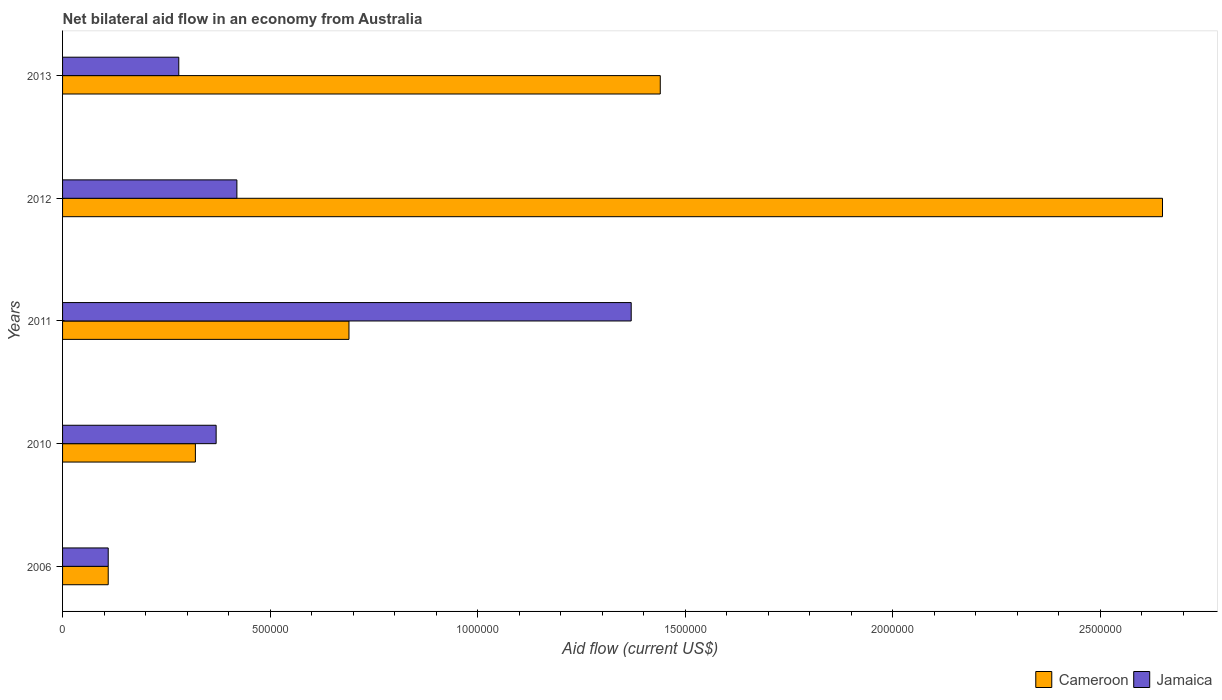How many different coloured bars are there?
Ensure brevity in your answer.  2. How many groups of bars are there?
Give a very brief answer. 5. Are the number of bars per tick equal to the number of legend labels?
Provide a succinct answer. Yes. Are the number of bars on each tick of the Y-axis equal?
Provide a short and direct response. Yes. How many bars are there on the 3rd tick from the top?
Provide a short and direct response. 2. How many bars are there on the 4th tick from the bottom?
Your answer should be compact. 2. Across all years, what is the maximum net bilateral aid flow in Jamaica?
Make the answer very short. 1.37e+06. What is the total net bilateral aid flow in Jamaica in the graph?
Provide a succinct answer. 2.55e+06. What is the difference between the net bilateral aid flow in Cameroon in 2006 and that in 2012?
Offer a terse response. -2.54e+06. What is the difference between the net bilateral aid flow in Jamaica in 2006 and the net bilateral aid flow in Cameroon in 2013?
Give a very brief answer. -1.33e+06. What is the average net bilateral aid flow in Jamaica per year?
Give a very brief answer. 5.10e+05. In how many years, is the net bilateral aid flow in Cameroon greater than 100000 US$?
Provide a succinct answer. 5. What is the ratio of the net bilateral aid flow in Jamaica in 2010 to that in 2011?
Your answer should be compact. 0.27. Is the difference between the net bilateral aid flow in Cameroon in 2010 and 2011 greater than the difference between the net bilateral aid flow in Jamaica in 2010 and 2011?
Give a very brief answer. Yes. What is the difference between the highest and the second highest net bilateral aid flow in Jamaica?
Offer a very short reply. 9.50e+05. What is the difference between the highest and the lowest net bilateral aid flow in Jamaica?
Give a very brief answer. 1.26e+06. Is the sum of the net bilateral aid flow in Jamaica in 2006 and 2013 greater than the maximum net bilateral aid flow in Cameroon across all years?
Offer a very short reply. No. What does the 1st bar from the top in 2006 represents?
Your response must be concise. Jamaica. What does the 2nd bar from the bottom in 2012 represents?
Offer a terse response. Jamaica. How many bars are there?
Keep it short and to the point. 10. What is the difference between two consecutive major ticks on the X-axis?
Provide a short and direct response. 5.00e+05. Are the values on the major ticks of X-axis written in scientific E-notation?
Provide a short and direct response. No. Does the graph contain any zero values?
Your response must be concise. No. How are the legend labels stacked?
Your response must be concise. Horizontal. What is the title of the graph?
Give a very brief answer. Net bilateral aid flow in an economy from Australia. Does "Albania" appear as one of the legend labels in the graph?
Offer a terse response. No. What is the label or title of the X-axis?
Make the answer very short. Aid flow (current US$). What is the Aid flow (current US$) of Cameroon in 2006?
Offer a terse response. 1.10e+05. What is the Aid flow (current US$) in Jamaica in 2006?
Your answer should be very brief. 1.10e+05. What is the Aid flow (current US$) of Cameroon in 2010?
Your answer should be very brief. 3.20e+05. What is the Aid flow (current US$) in Jamaica in 2010?
Provide a succinct answer. 3.70e+05. What is the Aid flow (current US$) of Cameroon in 2011?
Your answer should be compact. 6.90e+05. What is the Aid flow (current US$) of Jamaica in 2011?
Your answer should be compact. 1.37e+06. What is the Aid flow (current US$) of Cameroon in 2012?
Your response must be concise. 2.65e+06. What is the Aid flow (current US$) in Jamaica in 2012?
Provide a succinct answer. 4.20e+05. What is the Aid flow (current US$) of Cameroon in 2013?
Keep it short and to the point. 1.44e+06. What is the Aid flow (current US$) of Jamaica in 2013?
Offer a very short reply. 2.80e+05. Across all years, what is the maximum Aid flow (current US$) of Cameroon?
Make the answer very short. 2.65e+06. Across all years, what is the maximum Aid flow (current US$) of Jamaica?
Give a very brief answer. 1.37e+06. Across all years, what is the minimum Aid flow (current US$) in Cameroon?
Offer a very short reply. 1.10e+05. Across all years, what is the minimum Aid flow (current US$) in Jamaica?
Your answer should be very brief. 1.10e+05. What is the total Aid flow (current US$) of Cameroon in the graph?
Your response must be concise. 5.21e+06. What is the total Aid flow (current US$) in Jamaica in the graph?
Ensure brevity in your answer.  2.55e+06. What is the difference between the Aid flow (current US$) in Cameroon in 2006 and that in 2011?
Your answer should be compact. -5.80e+05. What is the difference between the Aid flow (current US$) of Jamaica in 2006 and that in 2011?
Your response must be concise. -1.26e+06. What is the difference between the Aid flow (current US$) in Cameroon in 2006 and that in 2012?
Ensure brevity in your answer.  -2.54e+06. What is the difference between the Aid flow (current US$) of Jamaica in 2006 and that in 2012?
Make the answer very short. -3.10e+05. What is the difference between the Aid flow (current US$) of Cameroon in 2006 and that in 2013?
Your answer should be very brief. -1.33e+06. What is the difference between the Aid flow (current US$) of Jamaica in 2006 and that in 2013?
Your response must be concise. -1.70e+05. What is the difference between the Aid flow (current US$) in Cameroon in 2010 and that in 2011?
Keep it short and to the point. -3.70e+05. What is the difference between the Aid flow (current US$) in Jamaica in 2010 and that in 2011?
Your answer should be very brief. -1.00e+06. What is the difference between the Aid flow (current US$) in Cameroon in 2010 and that in 2012?
Your response must be concise. -2.33e+06. What is the difference between the Aid flow (current US$) of Cameroon in 2010 and that in 2013?
Your answer should be very brief. -1.12e+06. What is the difference between the Aid flow (current US$) in Cameroon in 2011 and that in 2012?
Your response must be concise. -1.96e+06. What is the difference between the Aid flow (current US$) of Jamaica in 2011 and that in 2012?
Provide a short and direct response. 9.50e+05. What is the difference between the Aid flow (current US$) in Cameroon in 2011 and that in 2013?
Your response must be concise. -7.50e+05. What is the difference between the Aid flow (current US$) in Jamaica in 2011 and that in 2013?
Ensure brevity in your answer.  1.09e+06. What is the difference between the Aid flow (current US$) of Cameroon in 2012 and that in 2013?
Provide a short and direct response. 1.21e+06. What is the difference between the Aid flow (current US$) of Cameroon in 2006 and the Aid flow (current US$) of Jamaica in 2010?
Your answer should be very brief. -2.60e+05. What is the difference between the Aid flow (current US$) in Cameroon in 2006 and the Aid flow (current US$) in Jamaica in 2011?
Provide a succinct answer. -1.26e+06. What is the difference between the Aid flow (current US$) in Cameroon in 2006 and the Aid flow (current US$) in Jamaica in 2012?
Your response must be concise. -3.10e+05. What is the difference between the Aid flow (current US$) in Cameroon in 2006 and the Aid flow (current US$) in Jamaica in 2013?
Your response must be concise. -1.70e+05. What is the difference between the Aid flow (current US$) of Cameroon in 2010 and the Aid flow (current US$) of Jamaica in 2011?
Provide a succinct answer. -1.05e+06. What is the difference between the Aid flow (current US$) of Cameroon in 2012 and the Aid flow (current US$) of Jamaica in 2013?
Provide a short and direct response. 2.37e+06. What is the average Aid flow (current US$) of Cameroon per year?
Your answer should be compact. 1.04e+06. What is the average Aid flow (current US$) in Jamaica per year?
Keep it short and to the point. 5.10e+05. In the year 2010, what is the difference between the Aid flow (current US$) in Cameroon and Aid flow (current US$) in Jamaica?
Your answer should be very brief. -5.00e+04. In the year 2011, what is the difference between the Aid flow (current US$) in Cameroon and Aid flow (current US$) in Jamaica?
Keep it short and to the point. -6.80e+05. In the year 2012, what is the difference between the Aid flow (current US$) of Cameroon and Aid flow (current US$) of Jamaica?
Provide a succinct answer. 2.23e+06. In the year 2013, what is the difference between the Aid flow (current US$) of Cameroon and Aid flow (current US$) of Jamaica?
Ensure brevity in your answer.  1.16e+06. What is the ratio of the Aid flow (current US$) in Cameroon in 2006 to that in 2010?
Offer a very short reply. 0.34. What is the ratio of the Aid flow (current US$) of Jamaica in 2006 to that in 2010?
Offer a terse response. 0.3. What is the ratio of the Aid flow (current US$) of Cameroon in 2006 to that in 2011?
Offer a terse response. 0.16. What is the ratio of the Aid flow (current US$) in Jamaica in 2006 to that in 2011?
Give a very brief answer. 0.08. What is the ratio of the Aid flow (current US$) in Cameroon in 2006 to that in 2012?
Offer a very short reply. 0.04. What is the ratio of the Aid flow (current US$) of Jamaica in 2006 to that in 2012?
Provide a short and direct response. 0.26. What is the ratio of the Aid flow (current US$) of Cameroon in 2006 to that in 2013?
Your answer should be very brief. 0.08. What is the ratio of the Aid flow (current US$) of Jamaica in 2006 to that in 2013?
Keep it short and to the point. 0.39. What is the ratio of the Aid flow (current US$) of Cameroon in 2010 to that in 2011?
Keep it short and to the point. 0.46. What is the ratio of the Aid flow (current US$) of Jamaica in 2010 to that in 2011?
Keep it short and to the point. 0.27. What is the ratio of the Aid flow (current US$) of Cameroon in 2010 to that in 2012?
Offer a terse response. 0.12. What is the ratio of the Aid flow (current US$) in Jamaica in 2010 to that in 2012?
Your response must be concise. 0.88. What is the ratio of the Aid flow (current US$) of Cameroon in 2010 to that in 2013?
Keep it short and to the point. 0.22. What is the ratio of the Aid flow (current US$) of Jamaica in 2010 to that in 2013?
Provide a succinct answer. 1.32. What is the ratio of the Aid flow (current US$) in Cameroon in 2011 to that in 2012?
Provide a short and direct response. 0.26. What is the ratio of the Aid flow (current US$) of Jamaica in 2011 to that in 2012?
Your answer should be compact. 3.26. What is the ratio of the Aid flow (current US$) in Cameroon in 2011 to that in 2013?
Your answer should be very brief. 0.48. What is the ratio of the Aid flow (current US$) in Jamaica in 2011 to that in 2013?
Provide a succinct answer. 4.89. What is the ratio of the Aid flow (current US$) of Cameroon in 2012 to that in 2013?
Make the answer very short. 1.84. What is the ratio of the Aid flow (current US$) in Jamaica in 2012 to that in 2013?
Offer a terse response. 1.5. What is the difference between the highest and the second highest Aid flow (current US$) in Cameroon?
Make the answer very short. 1.21e+06. What is the difference between the highest and the second highest Aid flow (current US$) in Jamaica?
Your answer should be very brief. 9.50e+05. What is the difference between the highest and the lowest Aid flow (current US$) of Cameroon?
Offer a terse response. 2.54e+06. What is the difference between the highest and the lowest Aid flow (current US$) in Jamaica?
Your response must be concise. 1.26e+06. 